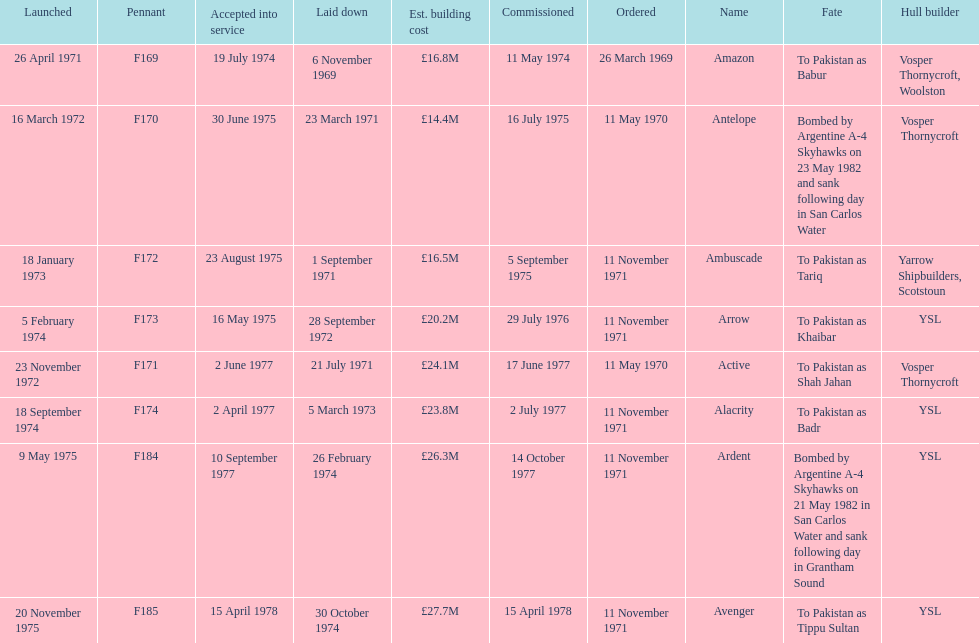What is the last listed pennant? F185. 